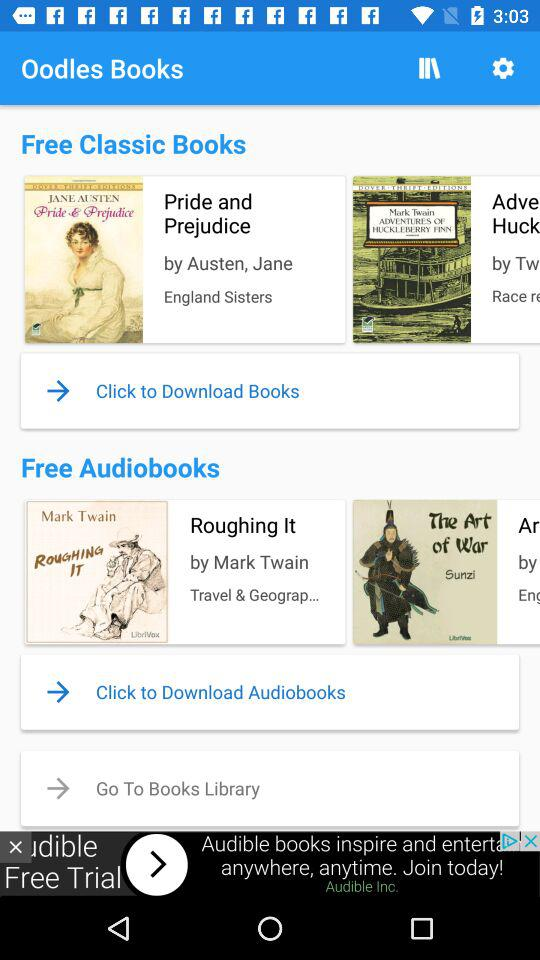Who is the author of the book "Pride and Prejudice"? The authors of the book "Pride and Prejudice" are Austen and Jane. 